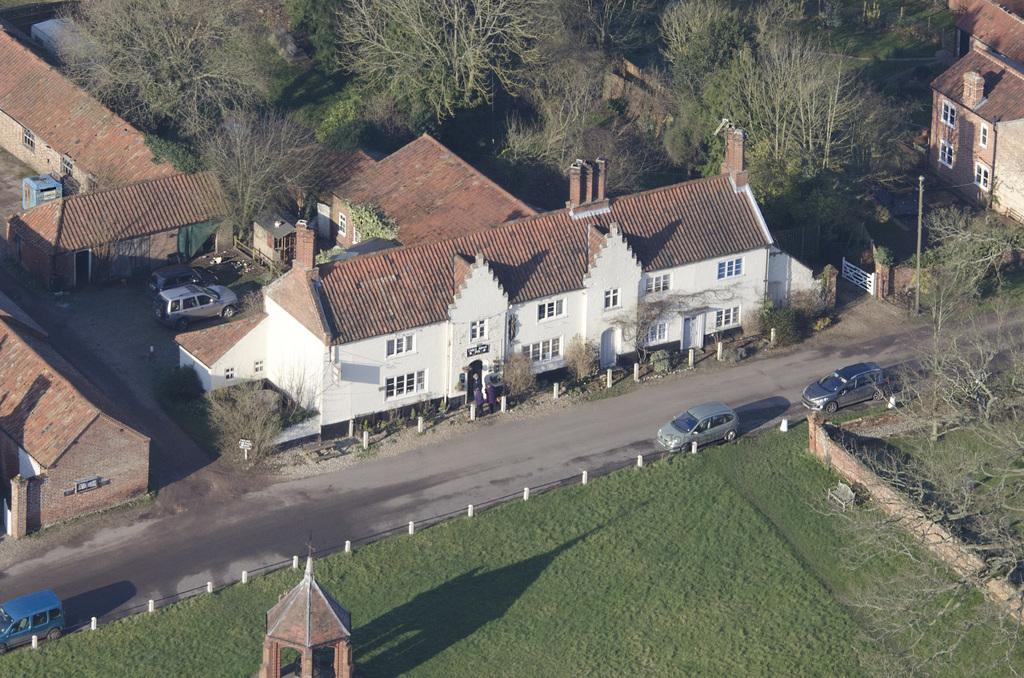What type of structures can be seen in the image? There are houses in the image. What type of vegetation is present in the image? There are trees and grass in the image. What type of pathway is visible in the image? There is a road in the image. What type of barriers are present in the image? There are walls in the image. What type of vehicles are present in the image? There are cars in the image. Can you see any snow in the image? There is no snow present in the image. What type of trade is happening between the houses in the image? There is no trade happening between the houses in the image; it is a still image. 